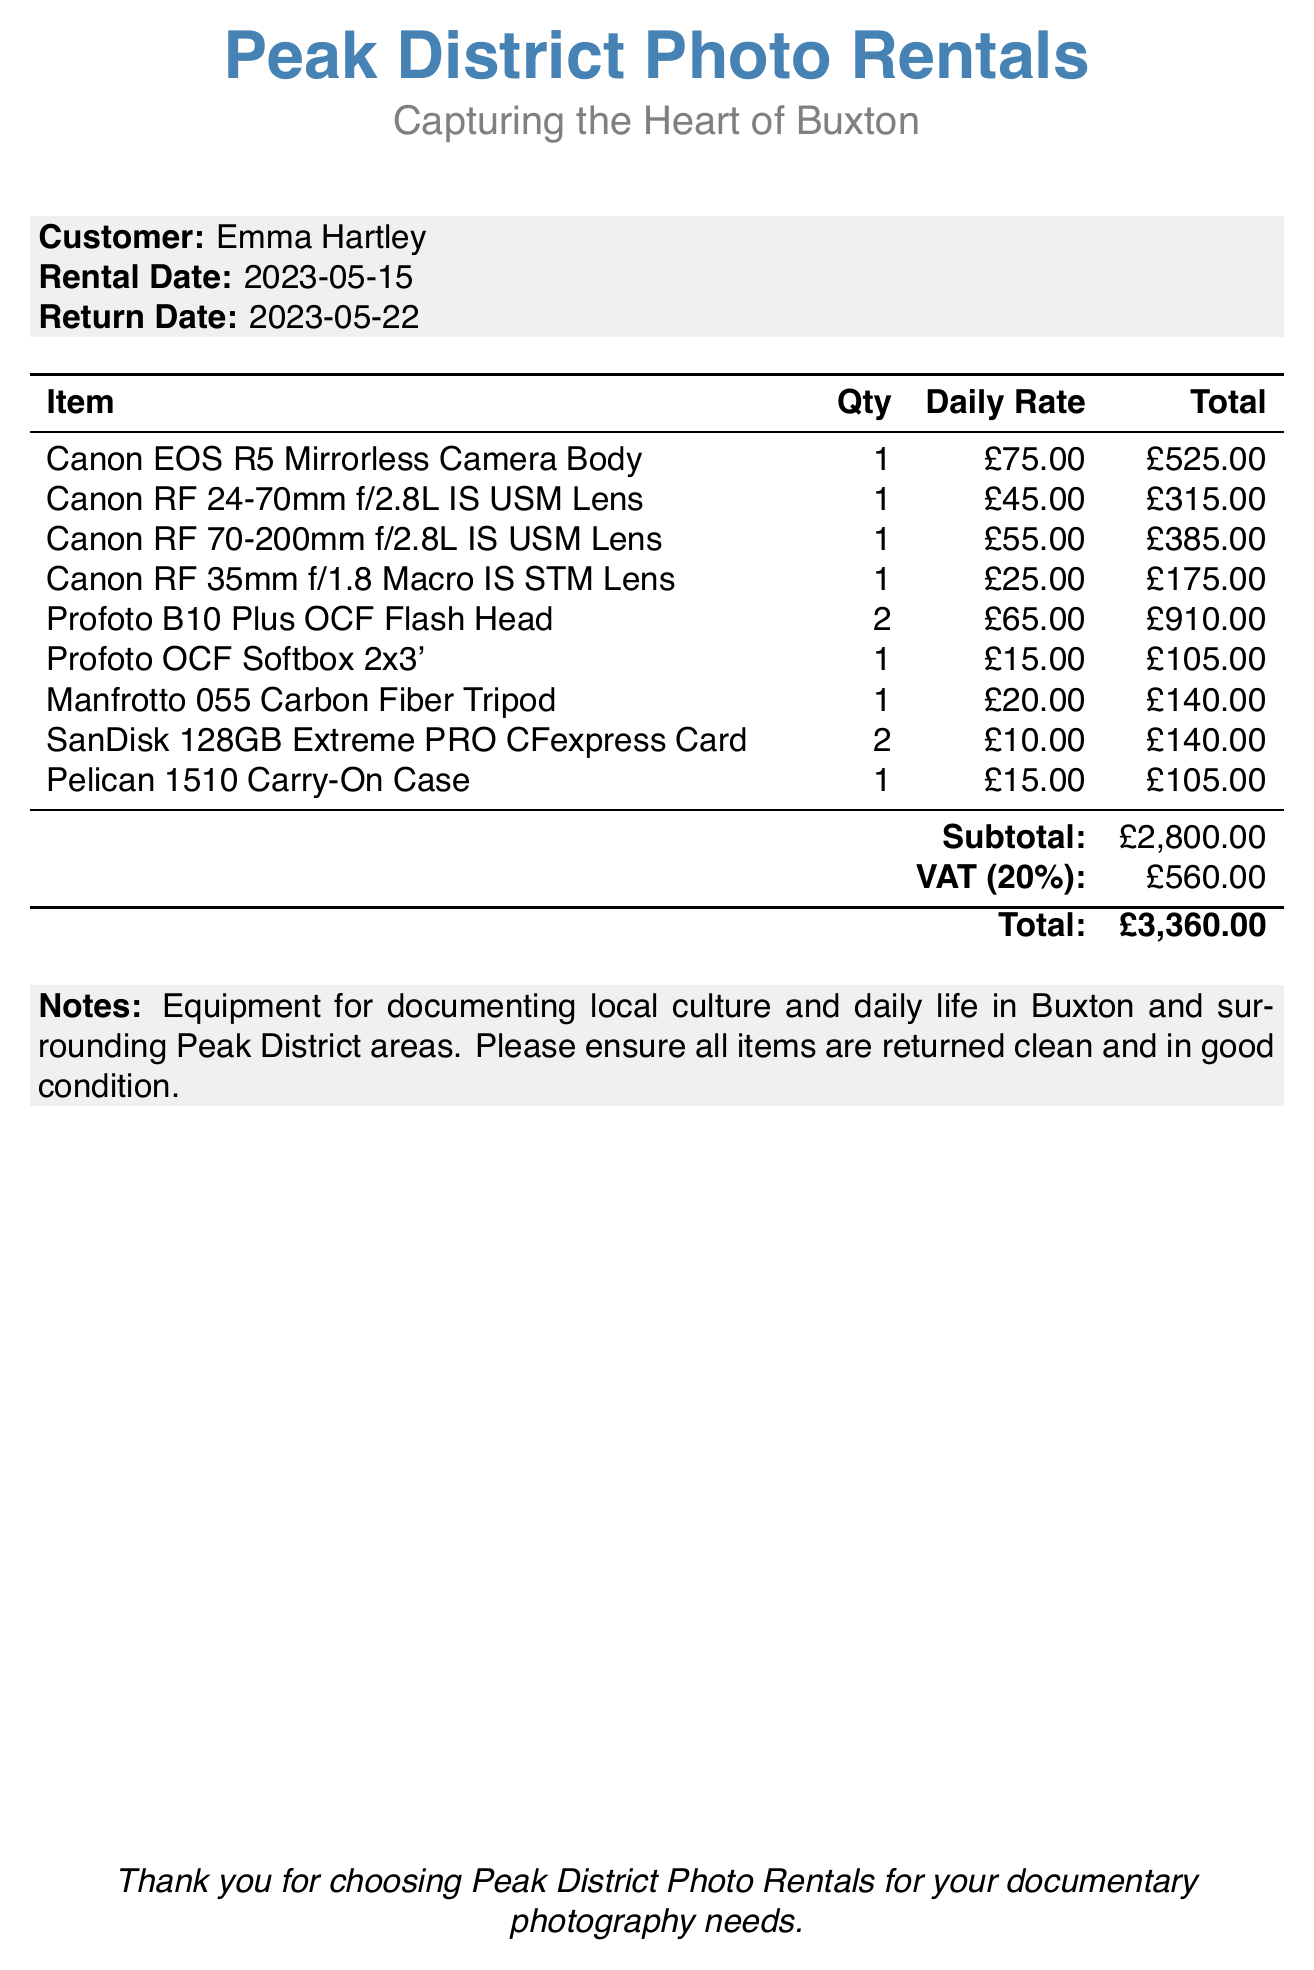What is the name of the rental company? The name of the rental company is specified in the document header.
Answer: Peak District Photo Rentals What is the customer’s name? The customer's name is clearly mentioned in the document.
Answer: Emma Hartley What is the rental date? The rental date is provided in the document under customer details.
Answer: 2023-05-15 What is the return date? The return date is listed alongside the rental date.
Answer: 2023-05-22 How many Canon RF 70-200mm lenses were rented? The quantity of the Canon RF 70-200mm lens is mentioned in the itemized list.
Answer: 1 What was the subtotal amount? The subtotal amount is the sum of all item totals before tax.
Answer: £2,800.00 What is the VAT amount? The VAT is detailed towards the end of the invoice.
Answer: £560.00 What is the total amount due? The total amount is calculated as the subtotal plus VAT.
Answer: £3,360.00 How many SanDisk CFexpress cards were rented? The quantity of the SanDisk CFexpress Card is provided in the itemized list.
Answer: 2 What is the note mentioning regarding the equipment? The note details the purpose of the rented equipment.
Answer: Equipment for documenting local culture and daily life in Buxton and surrounding Peak District areas. Please ensure all items are returned clean and in good condition 